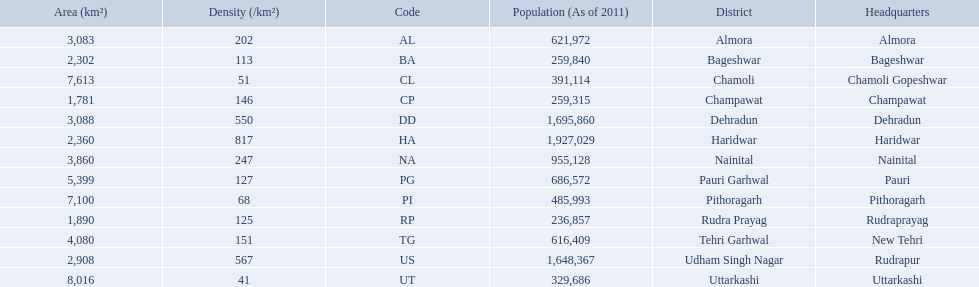What are the values for density of the districts of uttrakhand? 202, 113, 51, 146, 550, 817, 247, 127, 68, 125, 151, 567, 41. Which district has value of 51? Chamoli. 